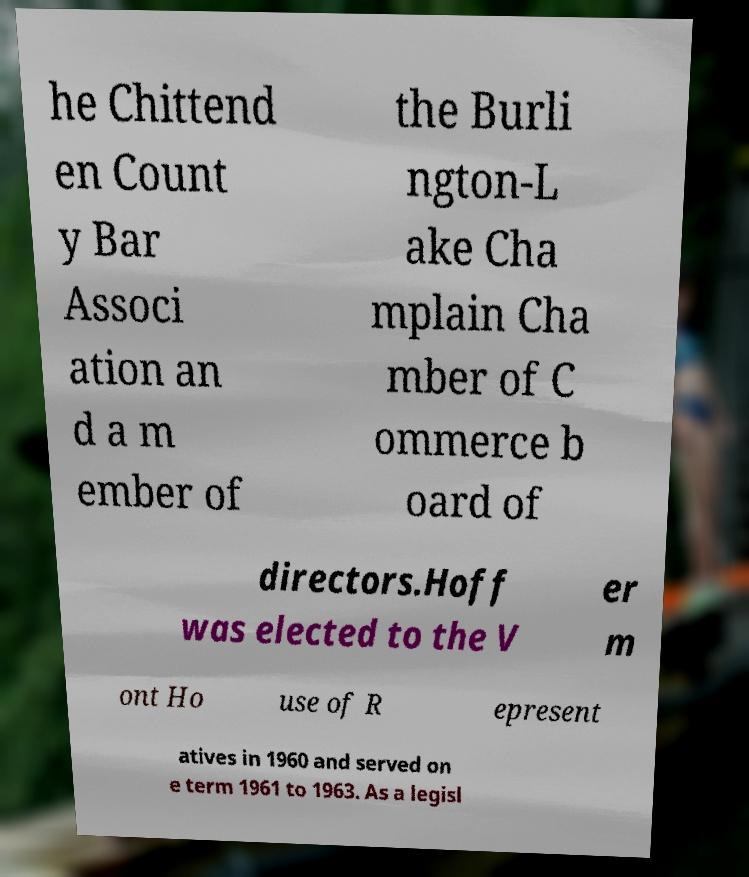Can you accurately transcribe the text from the provided image for me? he Chittend en Count y Bar Associ ation an d a m ember of the Burli ngton-L ake Cha mplain Cha mber of C ommerce b oard of directors.Hoff was elected to the V er m ont Ho use of R epresent atives in 1960 and served on e term 1961 to 1963. As a legisl 